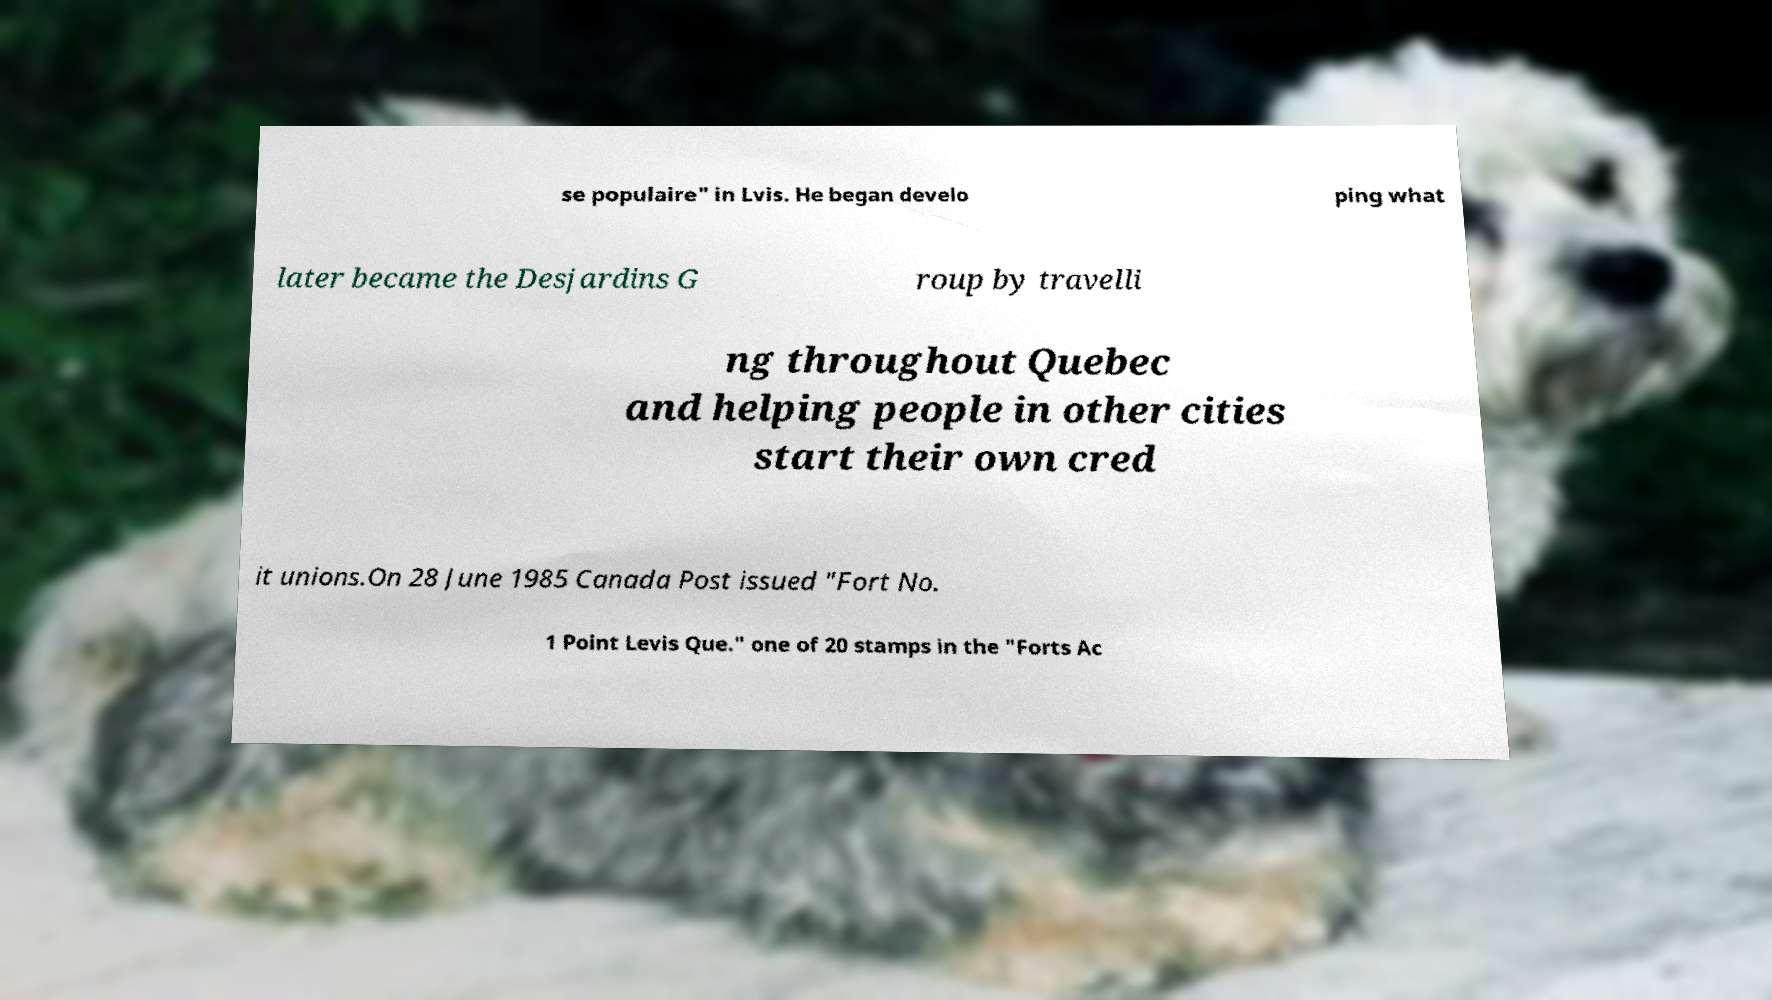I need the written content from this picture converted into text. Can you do that? se populaire" in Lvis. He began develo ping what later became the Desjardins G roup by travelli ng throughout Quebec and helping people in other cities start their own cred it unions.On 28 June 1985 Canada Post issued "Fort No. 1 Point Levis Que." one of 20 stamps in the "Forts Ac 